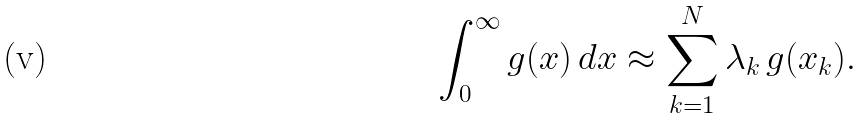<formula> <loc_0><loc_0><loc_500><loc_500>\int ^ { \infty } _ { 0 } g ( x ) \, d x \approx \sum ^ { N } _ { k = 1 } \lambda _ { k } \, g ( x _ { k } ) .</formula> 